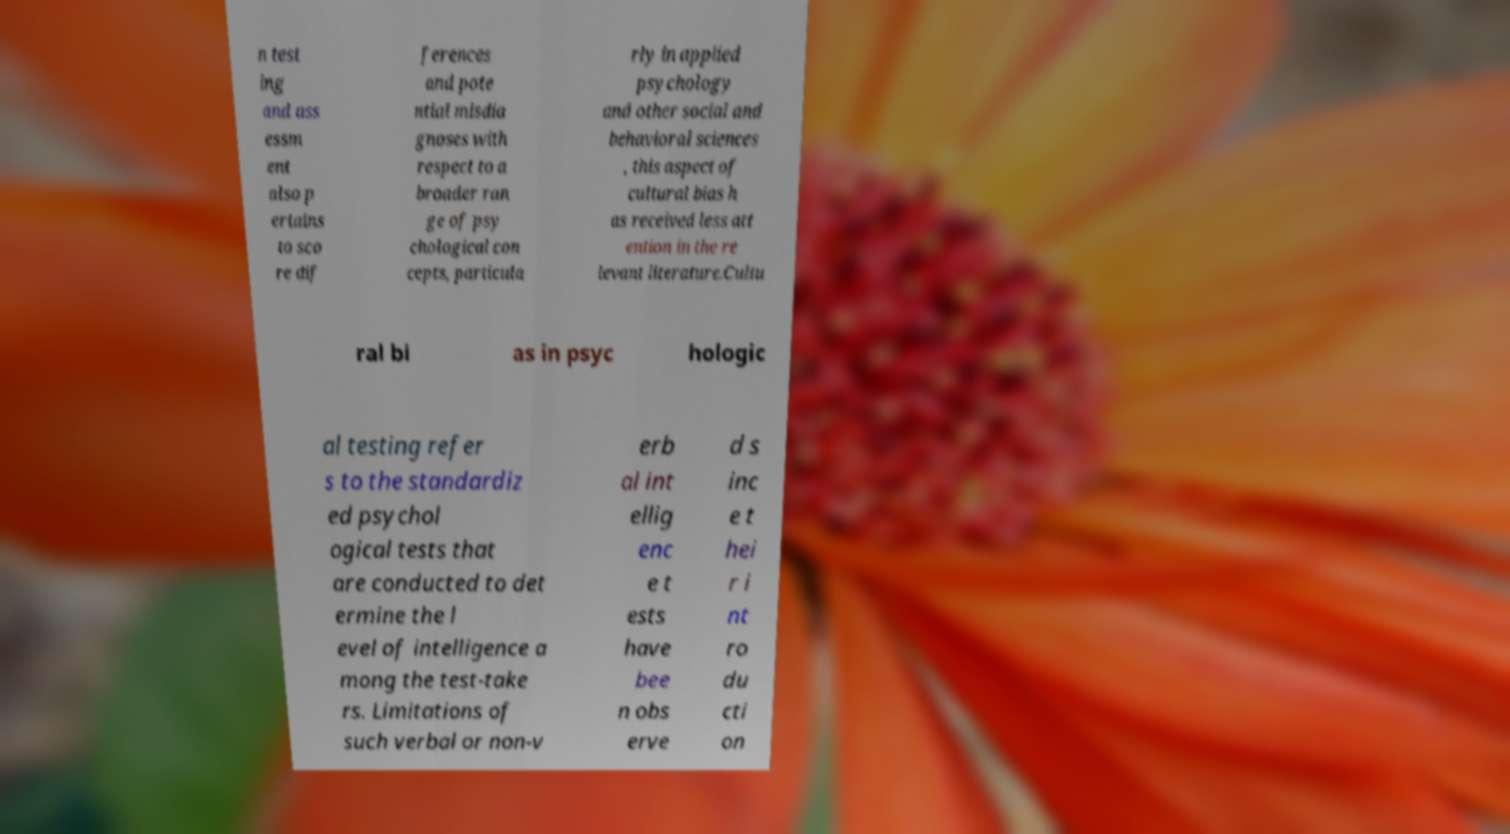Please identify and transcribe the text found in this image. n test ing and ass essm ent also p ertains to sco re dif ferences and pote ntial misdia gnoses with respect to a broader ran ge of psy chological con cepts, particula rly in applied psychology and other social and behavioral sciences , this aspect of cultural bias h as received less att ention in the re levant literature.Cultu ral bi as in psyc hologic al testing refer s to the standardiz ed psychol ogical tests that are conducted to det ermine the l evel of intelligence a mong the test-take rs. Limitations of such verbal or non-v erb al int ellig enc e t ests have bee n obs erve d s inc e t hei r i nt ro du cti on 